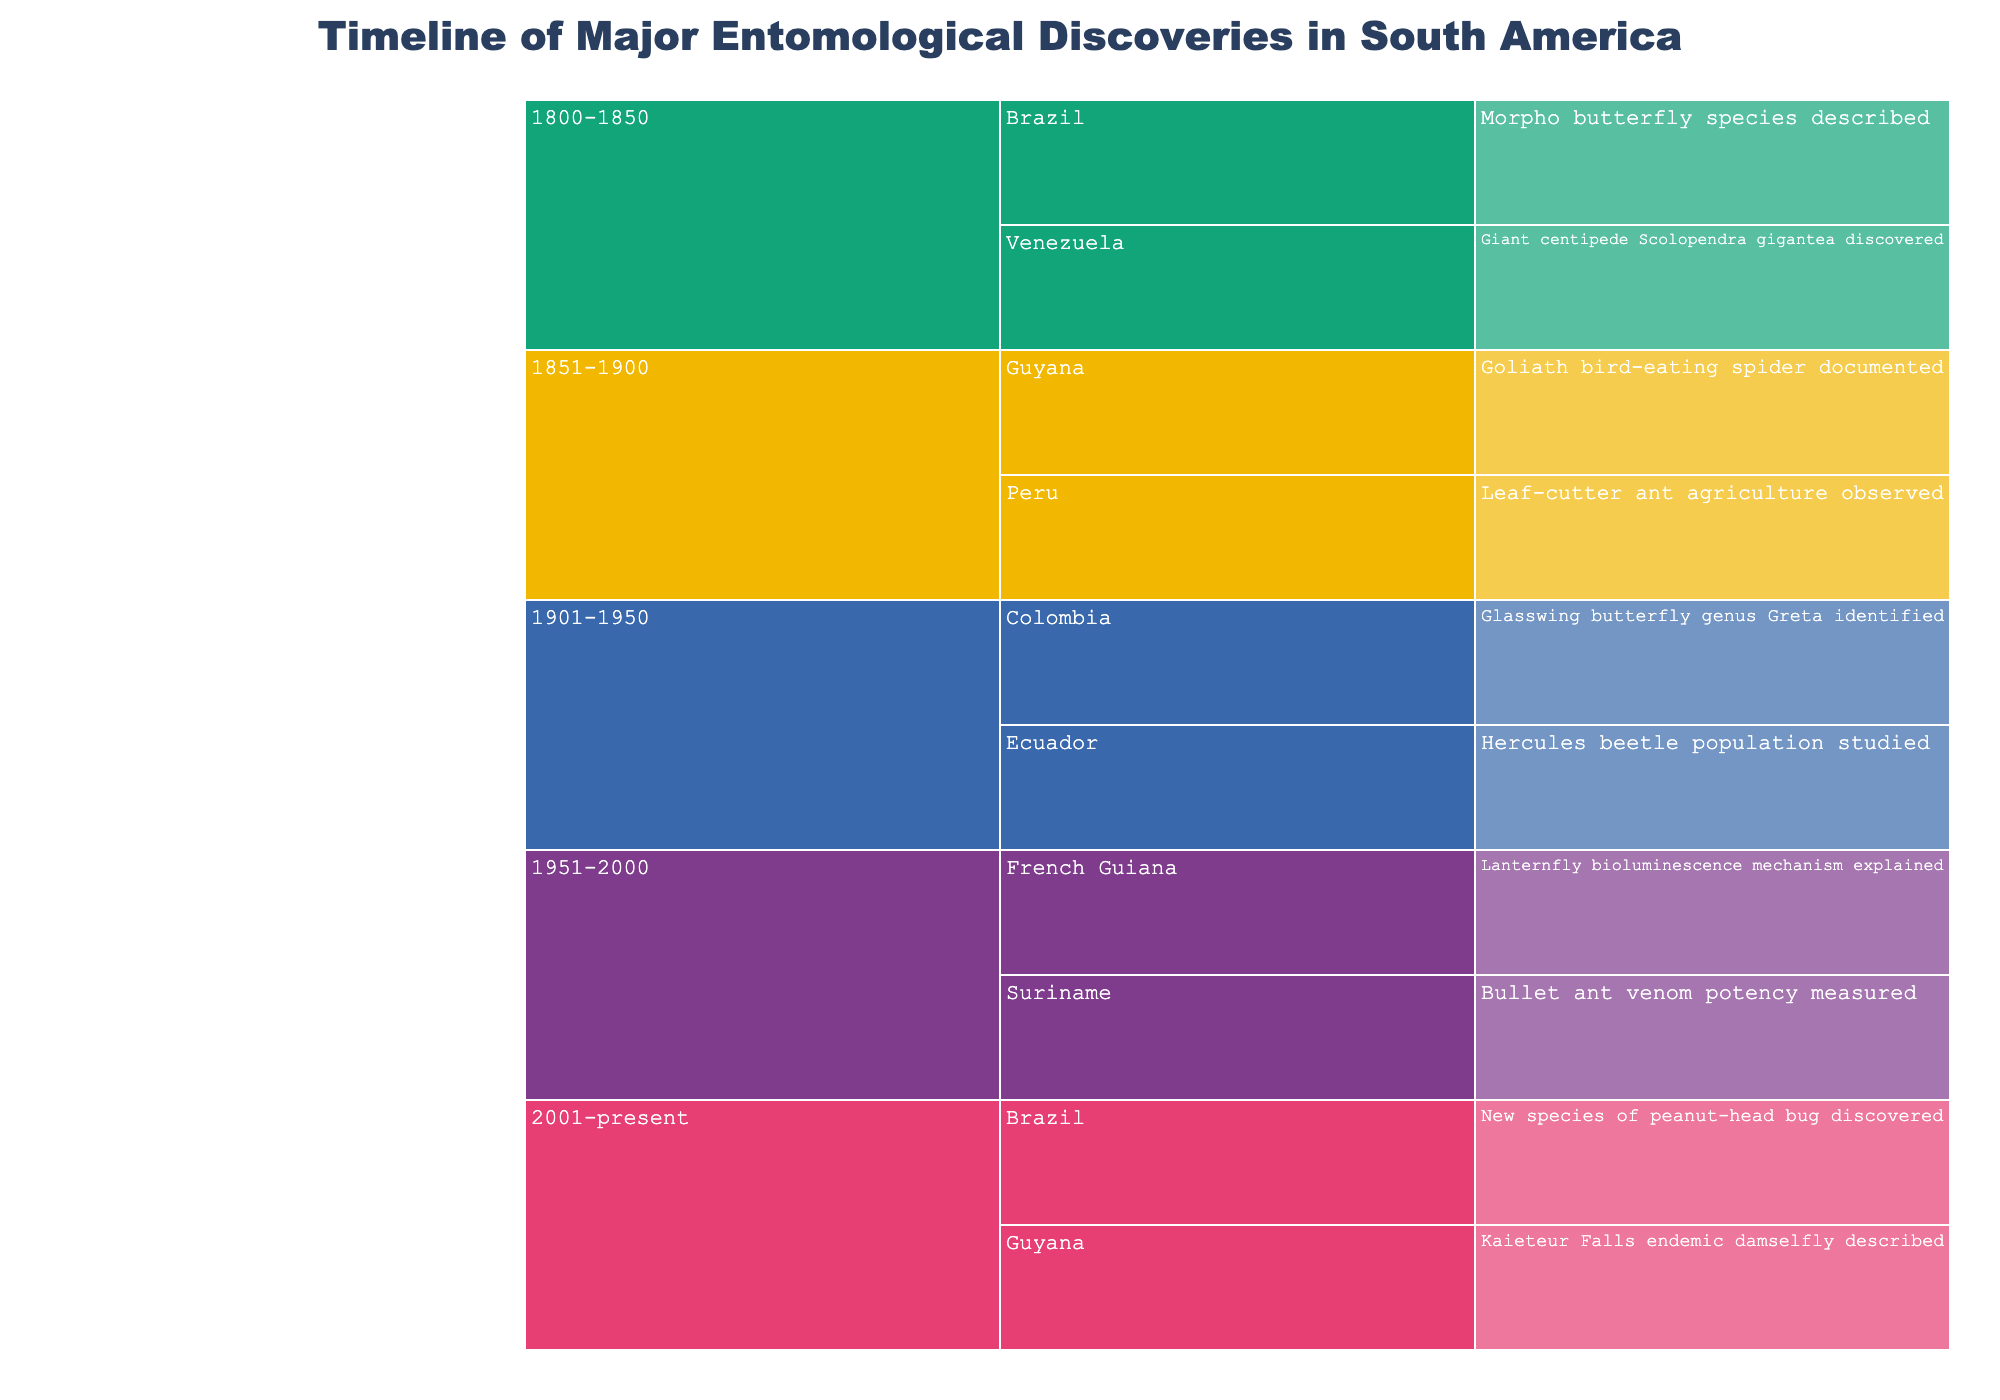What is the title of the icicle chart? The title is displayed at the top of the chart and should clearly indicate the main focus of the data being presented.
Answer: Timeline of Major Entomological Discoveries in South America How many regions are represented in the chart? Each region listed in the data is a unique entry under the time periods. Counting these entries will give the number of regions.
Answer: 8 Which region has discoveries in both the 1851-1900 and 2001-present time periods? By examining the figure closely, we can see which regions appear under both these time periods.
Answer: Guyana Which time period had the most discoveries recorded? Look at the branches representing each time period and count the number of discoveries under each. Identify the time period with the highest count.
Answer: 1901-1950 How many discoveries were made in Brazil? Navigate through the branches of the icicle chart to find the entries under Brazil and count them.
Answer: 2 What major discovery was recorded in Venezuela during the 1800-1850 time period? Trace the branch for Venezuela under the 1800-1850 time period to find the associated discovery.
Answer: Giant centipede Scolopendra gigantea discovered Compare the discoveries in Guyana and Suriname. Which country had discoveries earlier, and in which periods? Look at the branches for both Guyana and Suriname to determine the earliest time periods referenced and compare them.
Answer: Guyana had discoveries earlier (1851-1900) compared to Suriname (1951-2000) Identify a discovery related to ants in the figure. In which region and time period was it made? Scan the discoveries for keywords related to ants to identify relevant entries and note their respective regions and time periods.
Answer: Leaf-cutter ant agriculture observed in Peru during 1851-1900 How many discoveries were documented in the 2001-present time period? Check under the 2001-present branch and count the number of discoveries listed.
Answer: 2 What patterns or insights can be observed regarding the concentration of discoveries over time? Analyzing the distribution of discoveries across time periods can reveal trends in research activity and focus in entomology in South America.
Answer: Concentration of discoveries is higher in mid-time periods, notably 1901-1950 